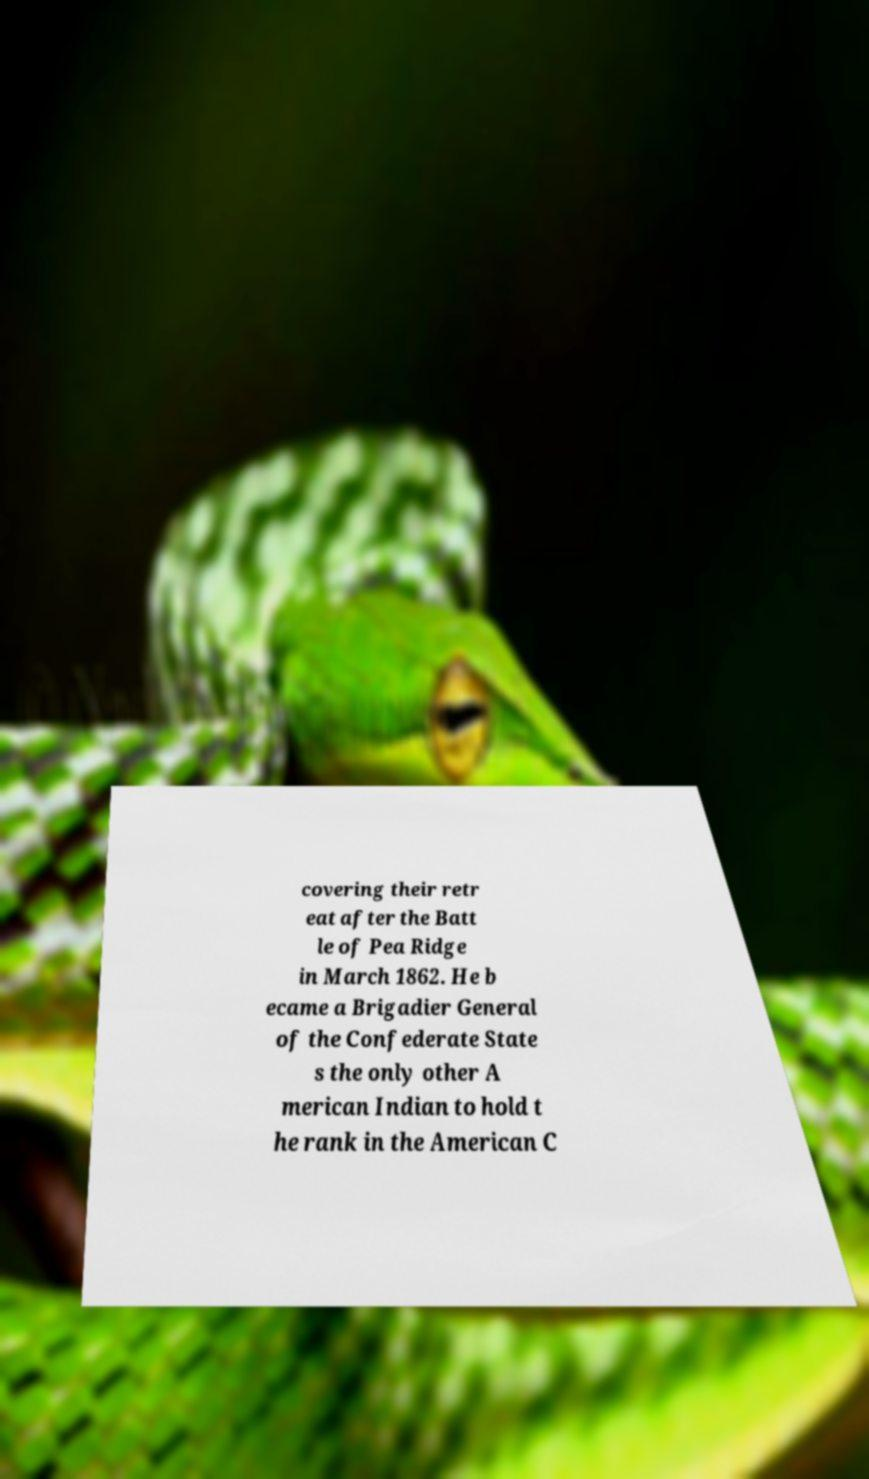I need the written content from this picture converted into text. Can you do that? covering their retr eat after the Batt le of Pea Ridge in March 1862. He b ecame a Brigadier General of the Confederate State s the only other A merican Indian to hold t he rank in the American C 